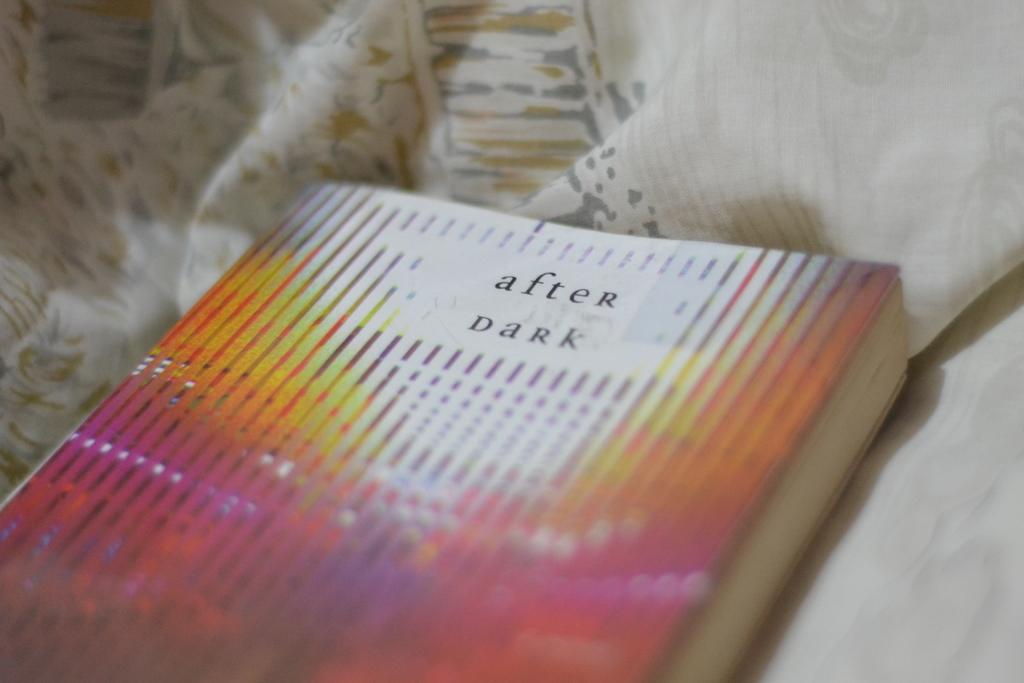Provide a one-sentence caption for the provided image. Paperback After Dark book is set in pastel material. 